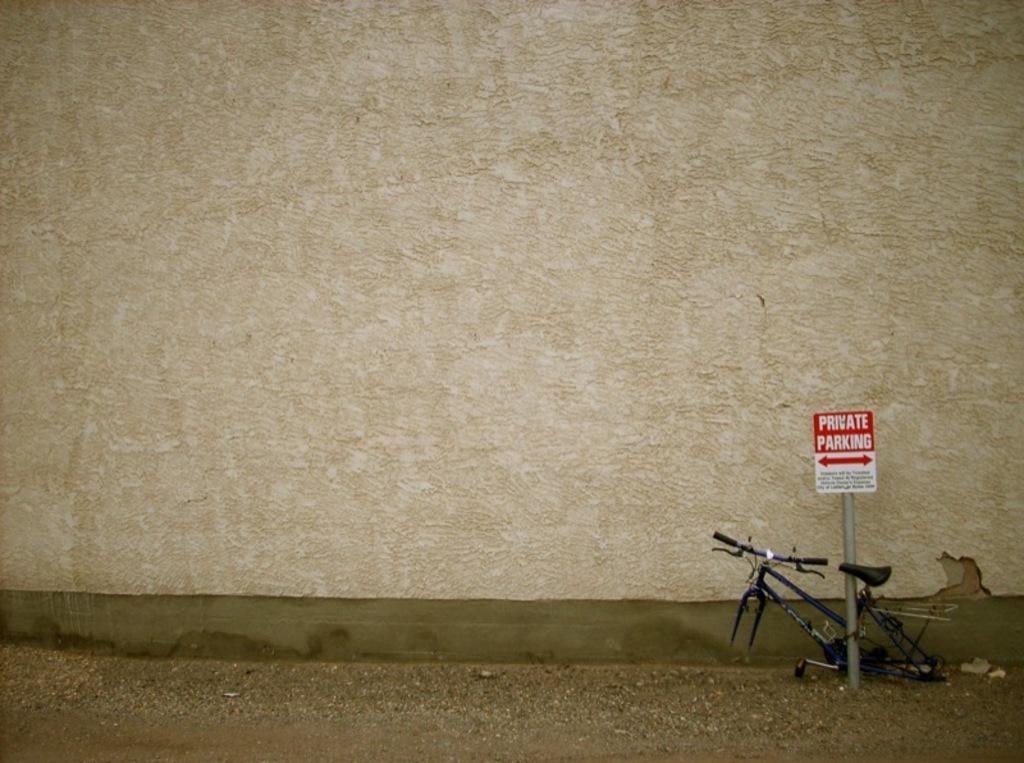Could you give a brief overview of what you see in this image? In this image I can see on the right side there is the frame of a cycle and a parking board in red color and this is the wall. 